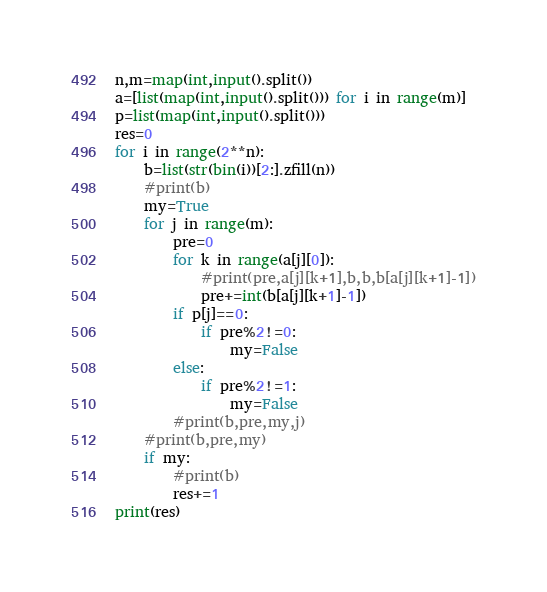Convert code to text. <code><loc_0><loc_0><loc_500><loc_500><_Python_>n,m=map(int,input().split())
a=[list(map(int,input().split())) for i in range(m)]
p=list(map(int,input().split()))
res=0
for i in range(2**n):
    b=list(str(bin(i))[2:].zfill(n))
    #print(b)
    my=True
    for j in range(m):
        pre=0
        for k in range(a[j][0]):
            #print(pre,a[j][k+1],b,b,b[a[j][k+1]-1])
            pre+=int(b[a[j][k+1]-1])
        if p[j]==0:
            if pre%2!=0:
                my=False
        else:
            if pre%2!=1:
                my=False
        #print(b,pre,my,j)
    #print(b,pre,my)
    if my:
        #print(b)
        res+=1
print(res)
</code> 